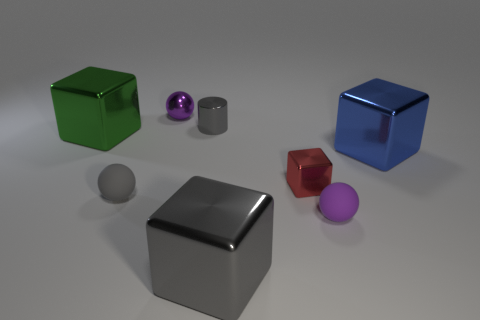What is the color of the small sphere that is on the right side of the gray rubber ball and in front of the purple metal ball?
Offer a very short reply. Purple. There is a purple sphere to the left of the shiny cylinder; does it have the same size as the large gray metal thing?
Provide a short and direct response. No. Is there anything else that is the same shape as the purple matte thing?
Provide a short and direct response. Yes. Are the green cube and the purple sphere that is on the left side of the tiny red object made of the same material?
Provide a short and direct response. Yes. What number of yellow objects are either large metal objects or cylinders?
Your response must be concise. 0. Are any blue metal cylinders visible?
Your answer should be very brief. No. There is a tiny purple thing behind the small sphere that is to the right of the large gray metal thing; are there any large green metallic blocks that are in front of it?
Ensure brevity in your answer.  Yes. Is there anything else that is the same size as the gray cylinder?
Your answer should be compact. Yes. There is a big green metallic thing; is its shape the same as the large metallic object in front of the red block?
Give a very brief answer. Yes. There is a big metallic cube in front of the big blue thing that is in front of the tiny purple thing behind the small red metallic thing; what color is it?
Provide a short and direct response. Gray. 